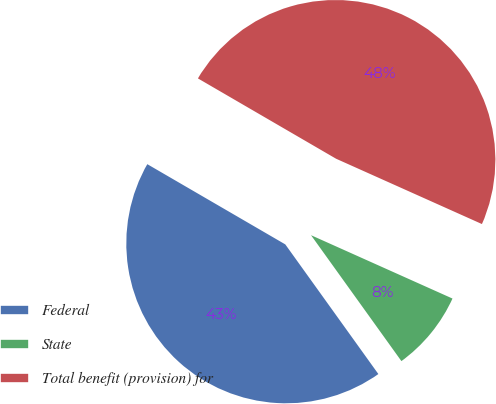<chart> <loc_0><loc_0><loc_500><loc_500><pie_chart><fcel>Federal<fcel>State<fcel>Total benefit (provision) for<nl><fcel>43.29%<fcel>8.39%<fcel>48.32%<nl></chart> 